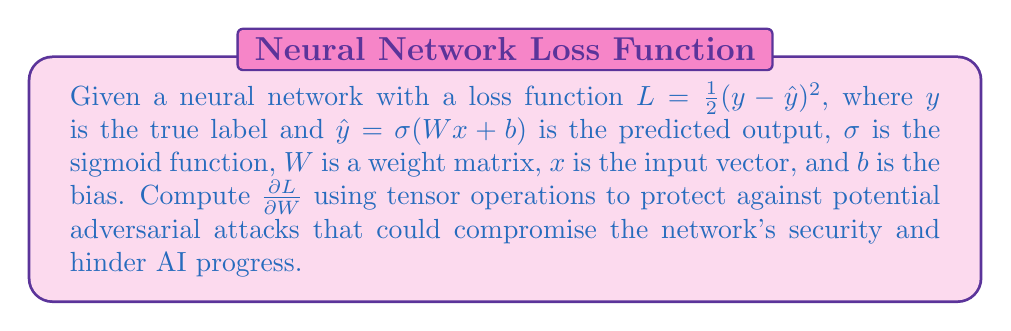Show me your answer to this math problem. To compute $\frac{\partial L}{\partial W}$, we'll use the chain rule and tensor operations:

1) First, let's express $L$ in terms of $\hat{y}$:
   $$L = \frac{1}{2}(y - \hat{y})^2$$

2) Apply the chain rule:
   $$\frac{\partial L}{\partial W} = \frac{\partial L}{\partial \hat{y}} \cdot \frac{\partial \hat{y}}{\partial z} \cdot \frac{\partial z}{\partial W}$$
   where $z = Wx + b$

3) Compute $\frac{\partial L}{\partial \hat{y}}$:
   $$\frac{\partial L}{\partial \hat{y}} = -(y - \hat{y}) = \hat{y} - y$$

4) Compute $\frac{\partial \hat{y}}{\partial z}$:
   $$\frac{\partial \hat{y}}{\partial z} = \frac{\partial \sigma(z)}{\partial z} = \sigma(z)(1 - \sigma(z)) = \hat{y}(1 - \hat{y})$$

5) Compute $\frac{\partial z}{\partial W}$:
   $$\frac{\partial z}{\partial W} = x^T$$

6) Combine the terms using tensor operations:
   $$\frac{\partial L}{\partial W} = (\hat{y} - y) \cdot \hat{y}(1 - \hat{y}) \cdot x^T$$

7) Simplify:
   $$\frac{\partial L}{\partial W} = (\hat{y} - y) \cdot \hat{y}(1 - \hat{y}) \otimes x$$
   where $\otimes$ denotes the outer product.

This gradient computation helps in securing the network against potential adversarial attacks by allowing for proper weight updates during training.
Answer: $$\frac{\partial L}{\partial W} = (\hat{y} - y) \cdot \hat{y}(1 - \hat{y}) \otimes x$$ 